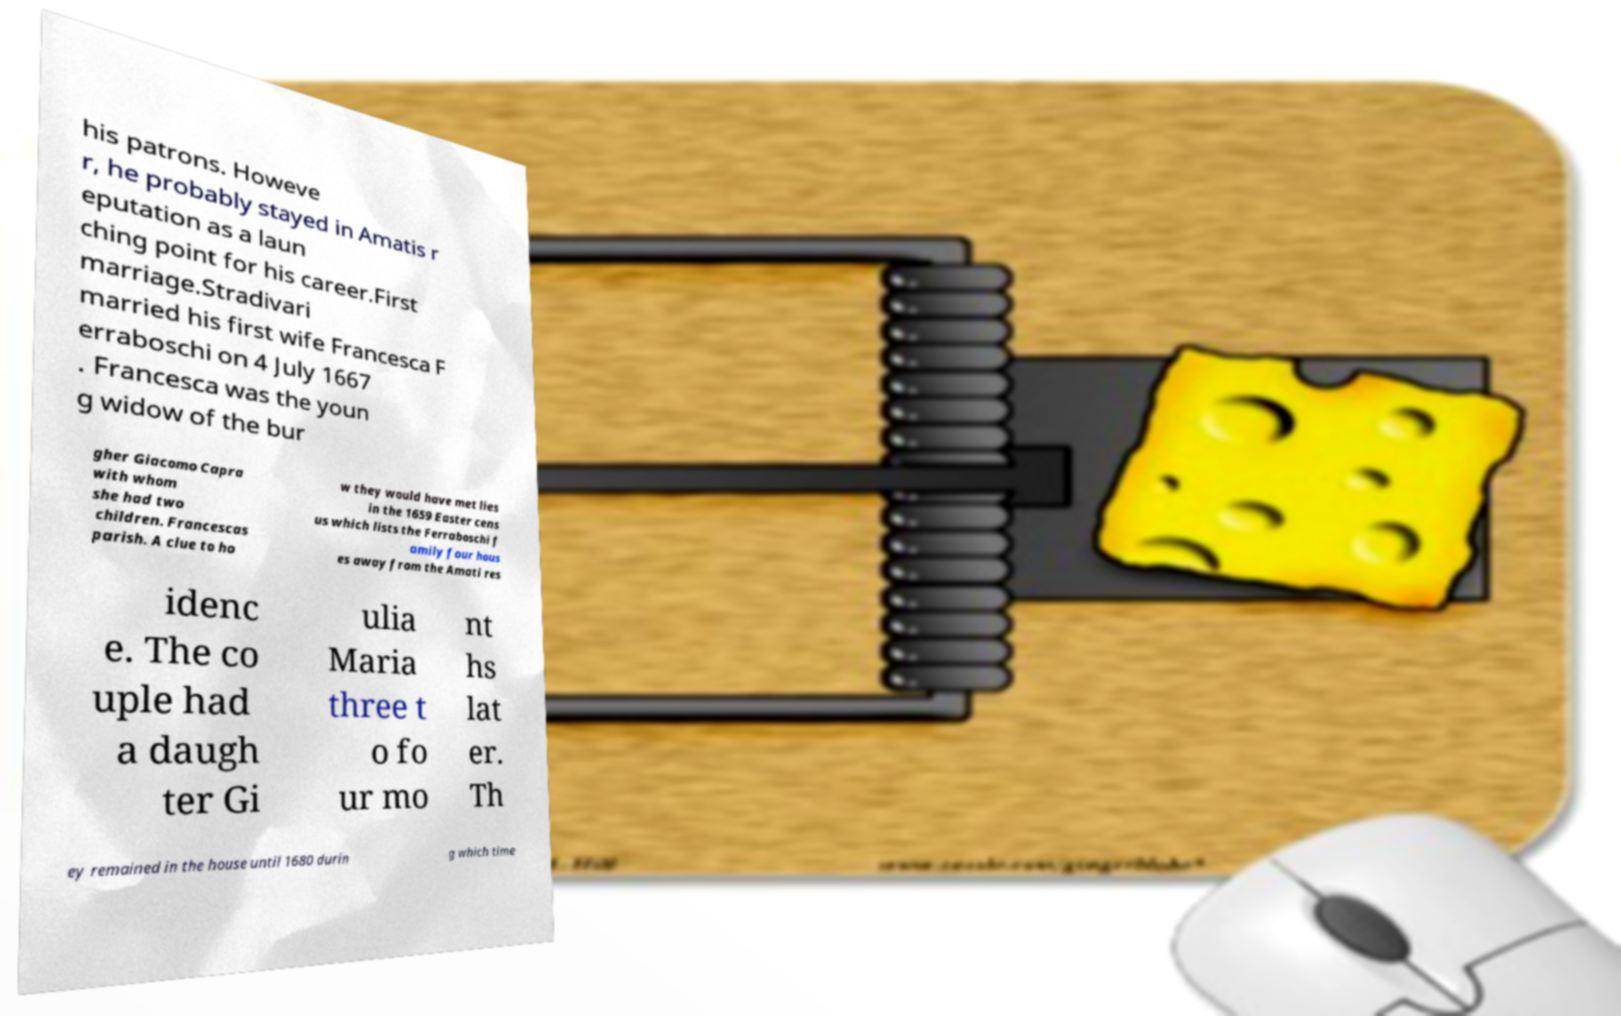Can you accurately transcribe the text from the provided image for me? his patrons. Howeve r, he probably stayed in Amatis r eputation as a laun ching point for his career.First marriage.Stradivari married his first wife Francesca F erraboschi on 4 July 1667 . Francesca was the youn g widow of the bur gher Giacomo Capra with whom she had two children. Francescas parish. A clue to ho w they would have met lies in the 1659 Easter cens us which lists the Ferraboschi f amily four hous es away from the Amati res idenc e. The co uple had a daugh ter Gi ulia Maria three t o fo ur mo nt hs lat er. Th ey remained in the house until 1680 durin g which time 